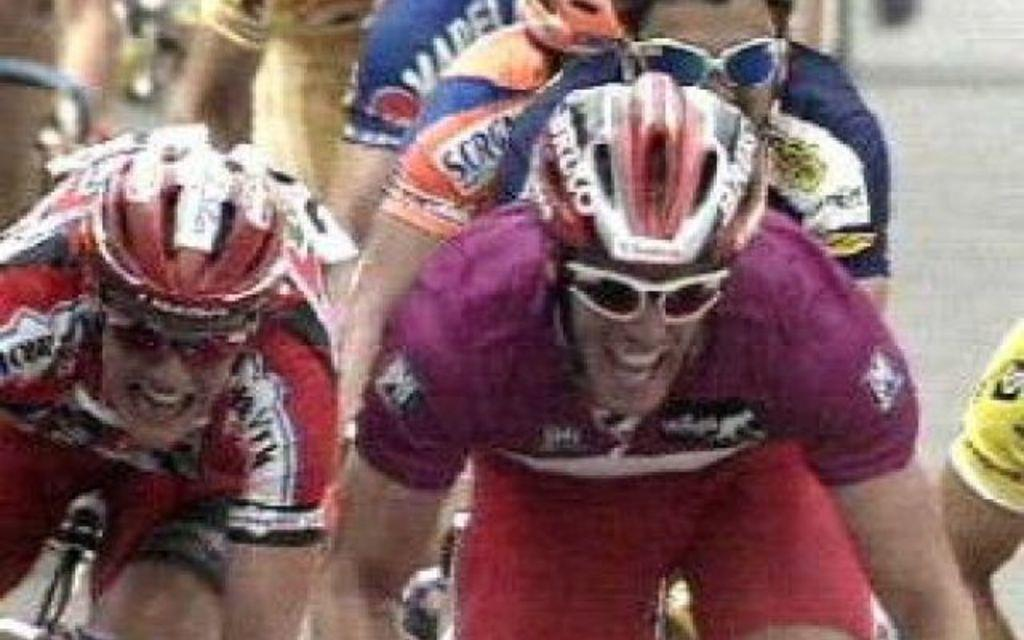Who is present in the image? There are people in the image. What are the people wearing on their upper bodies? The people are wearing t-shirts. What are the people wearing on their heads? The people are wearing helmets on their heads. What activity are the people engaged in? It appears that the people are riding bicycles. How many children are present in the image? The provided facts do not mention the presence of children in the image, so we cannot determine the number of children present. 